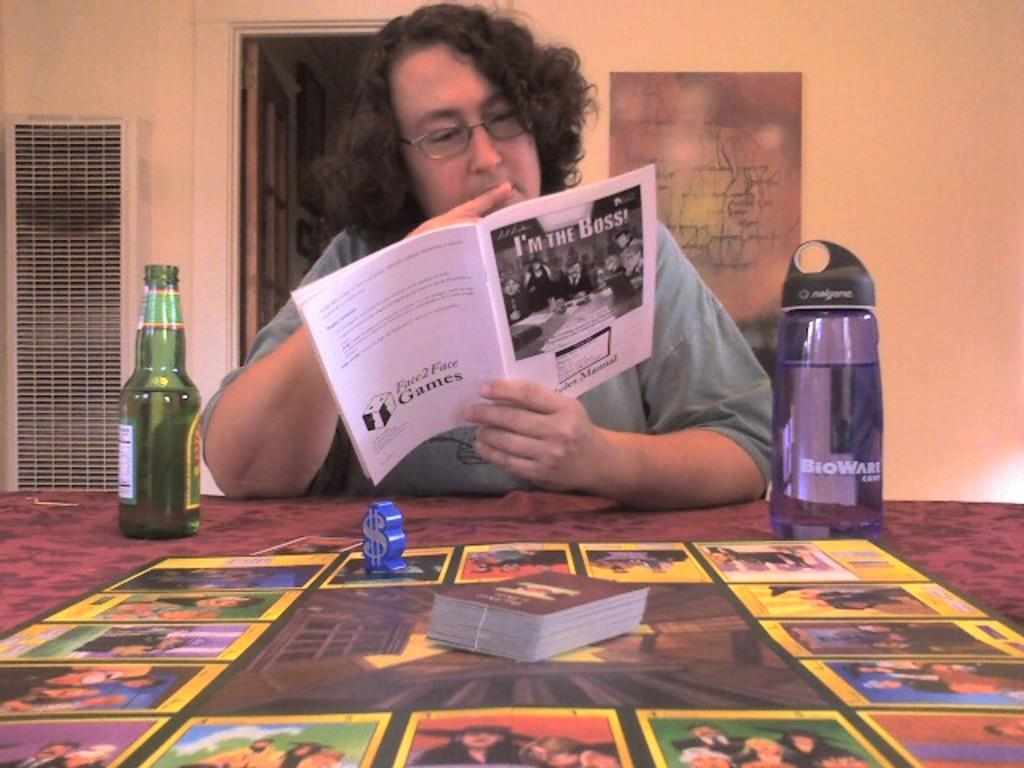<image>
Share a concise interpretation of the image provided. A person sits at a table reading from a booklet called I'm the Boss. 